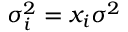Convert formula to latex. <formula><loc_0><loc_0><loc_500><loc_500>\sigma _ { i } ^ { 2 } = x _ { i } \sigma ^ { 2 }</formula> 